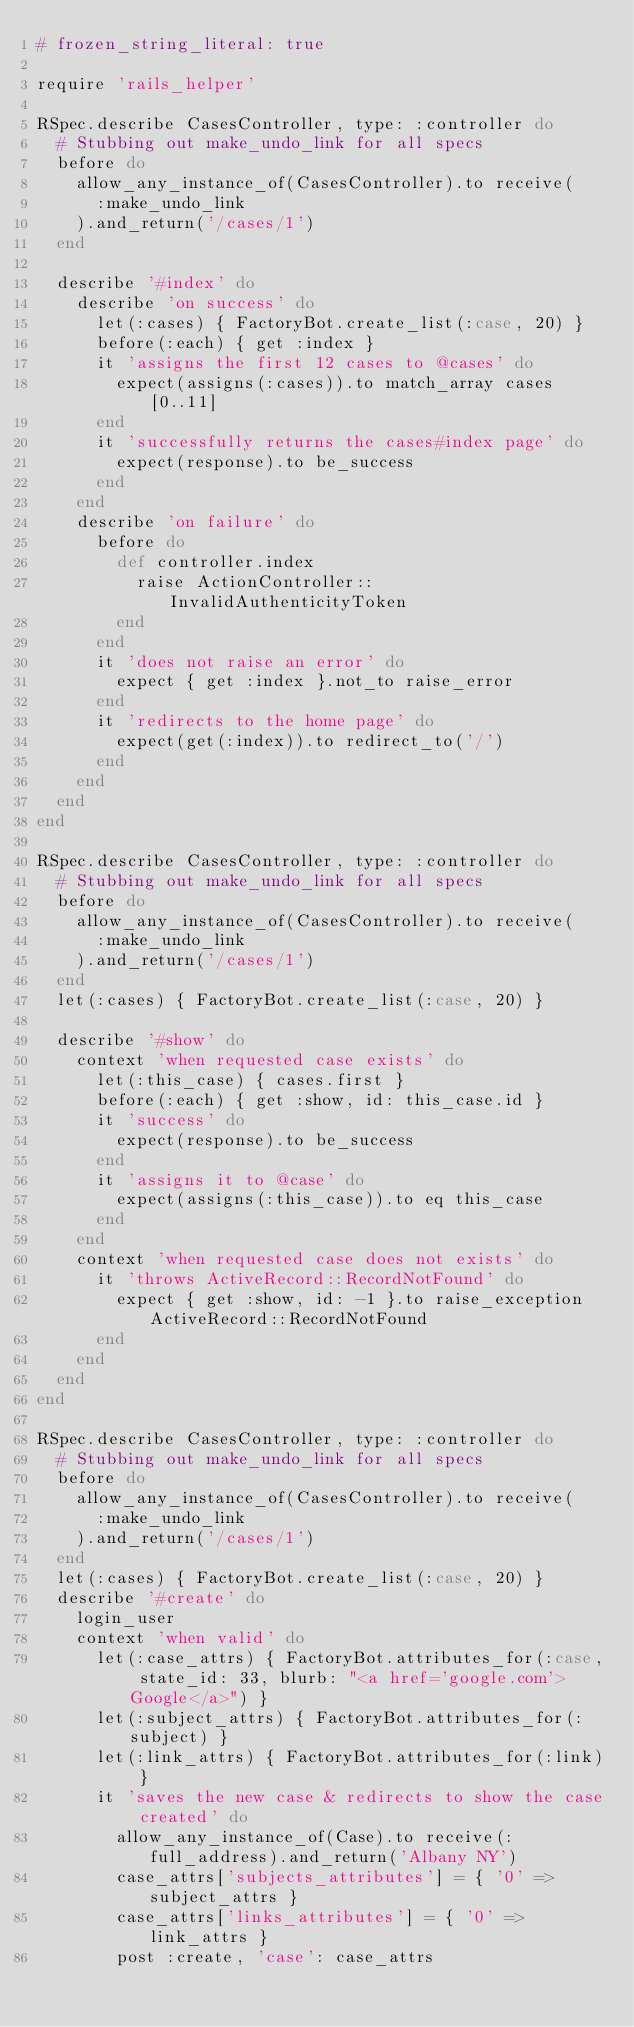<code> <loc_0><loc_0><loc_500><loc_500><_Ruby_># frozen_string_literal: true

require 'rails_helper'

RSpec.describe CasesController, type: :controller do
  # Stubbing out make_undo_link for all specs
  before do
    allow_any_instance_of(CasesController).to receive(
      :make_undo_link
    ).and_return('/cases/1')
  end

  describe '#index' do
    describe 'on success' do
      let(:cases) { FactoryBot.create_list(:case, 20) }
      before(:each) { get :index }
      it 'assigns the first 12 cases to @cases' do
        expect(assigns(:cases)).to match_array cases[0..11]
      end
      it 'successfully returns the cases#index page' do
        expect(response).to be_success
      end
    end
    describe 'on failure' do
      before do
        def controller.index
          raise ActionController::InvalidAuthenticityToken
        end
      end
      it 'does not raise an error' do
        expect { get :index }.not_to raise_error
      end
      it 'redirects to the home page' do
        expect(get(:index)).to redirect_to('/')
      end
    end
  end
end

RSpec.describe CasesController, type: :controller do
  # Stubbing out make_undo_link for all specs
  before do
    allow_any_instance_of(CasesController).to receive(
      :make_undo_link
    ).and_return('/cases/1')
  end
  let(:cases) { FactoryBot.create_list(:case, 20) }

  describe '#show' do
    context 'when requested case exists' do
      let(:this_case) { cases.first }
      before(:each) { get :show, id: this_case.id }
      it 'success' do
        expect(response).to be_success
      end
      it 'assigns it to @case' do
        expect(assigns(:this_case)).to eq this_case
      end
    end
    context 'when requested case does not exists' do
      it 'throws ActiveRecord::RecordNotFound' do
        expect { get :show, id: -1 }.to raise_exception ActiveRecord::RecordNotFound
      end
    end
  end
end

RSpec.describe CasesController, type: :controller do
  # Stubbing out make_undo_link for all specs
  before do
    allow_any_instance_of(CasesController).to receive(
      :make_undo_link
    ).and_return('/cases/1')
  end
  let(:cases) { FactoryBot.create_list(:case, 20) }
  describe '#create' do
    login_user
    context 'when valid' do
      let(:case_attrs) { FactoryBot.attributes_for(:case, state_id: 33, blurb: "<a href='google.com'>Google</a>") }
      let(:subject_attrs) { FactoryBot.attributes_for(:subject) }
      let(:link_attrs) { FactoryBot.attributes_for(:link) }
      it 'saves the new case & redirects to show the case created' do
        allow_any_instance_of(Case).to receive(:full_address).and_return('Albany NY')
        case_attrs['subjects_attributes'] = { '0' => subject_attrs }
        case_attrs['links_attributes'] = { '0' => link_attrs }
        post :create, 'case': case_attrs</code> 